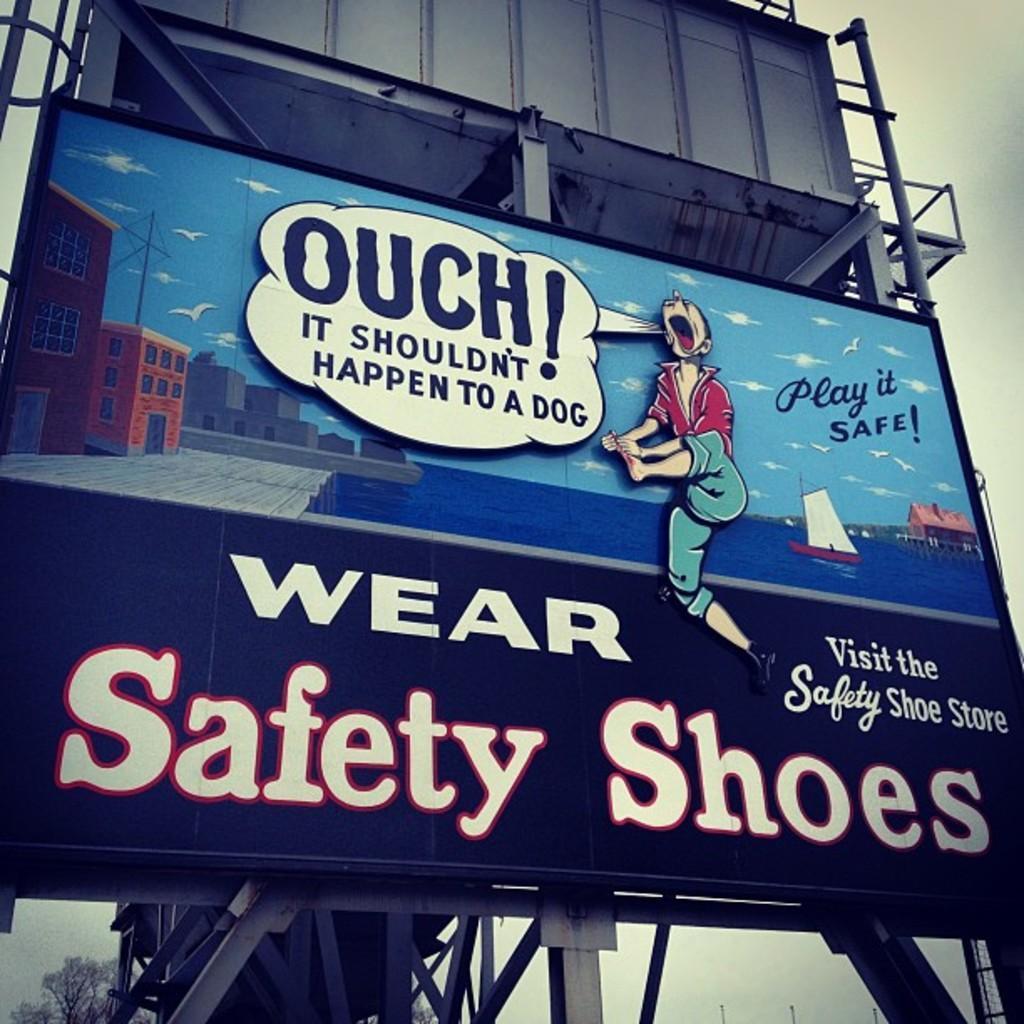Please provide a concise description of this image. Here I can see a board on which I can see some text and cartoon images. At the back of it there are metal rods. In the background, I can see the sky. In the bottom left-hand corner there is a tree. 